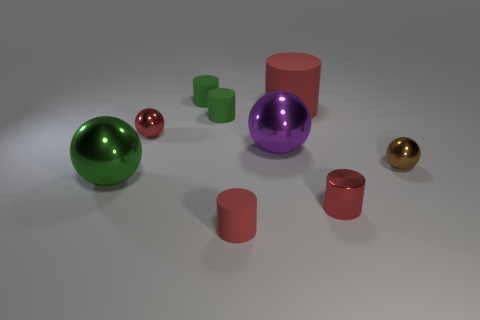Subtract all red cylinders. How many were subtracted if there are1red cylinders left? 2 Subtract all big green shiny balls. How many balls are left? 3 Add 1 large purple metal objects. How many objects exist? 10 Subtract all red spheres. How many spheres are left? 3 Subtract 0 green blocks. How many objects are left? 9 Subtract all spheres. How many objects are left? 5 Subtract 2 cylinders. How many cylinders are left? 3 Subtract all brown cylinders. Subtract all yellow cubes. How many cylinders are left? 5 Subtract all yellow spheres. How many green cylinders are left? 2 Subtract all big red rubber cylinders. Subtract all red spheres. How many objects are left? 7 